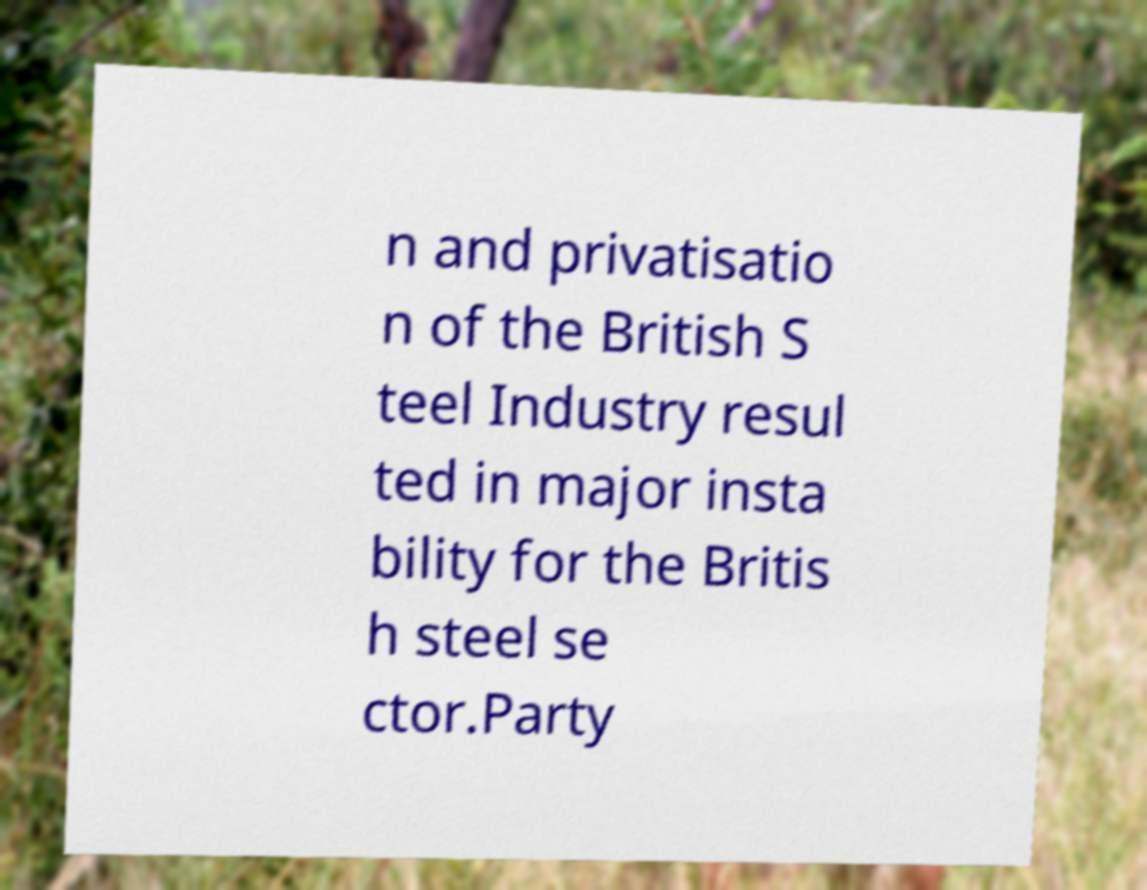For documentation purposes, I need the text within this image transcribed. Could you provide that? n and privatisatio n of the British S teel Industry resul ted in major insta bility for the Britis h steel se ctor.Party 